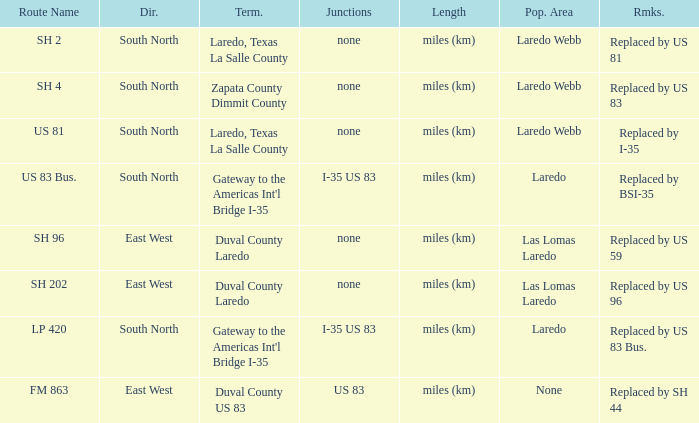What unit of length is being used for the route with "replaced by us 81" in their remarks section? Miles (km). 